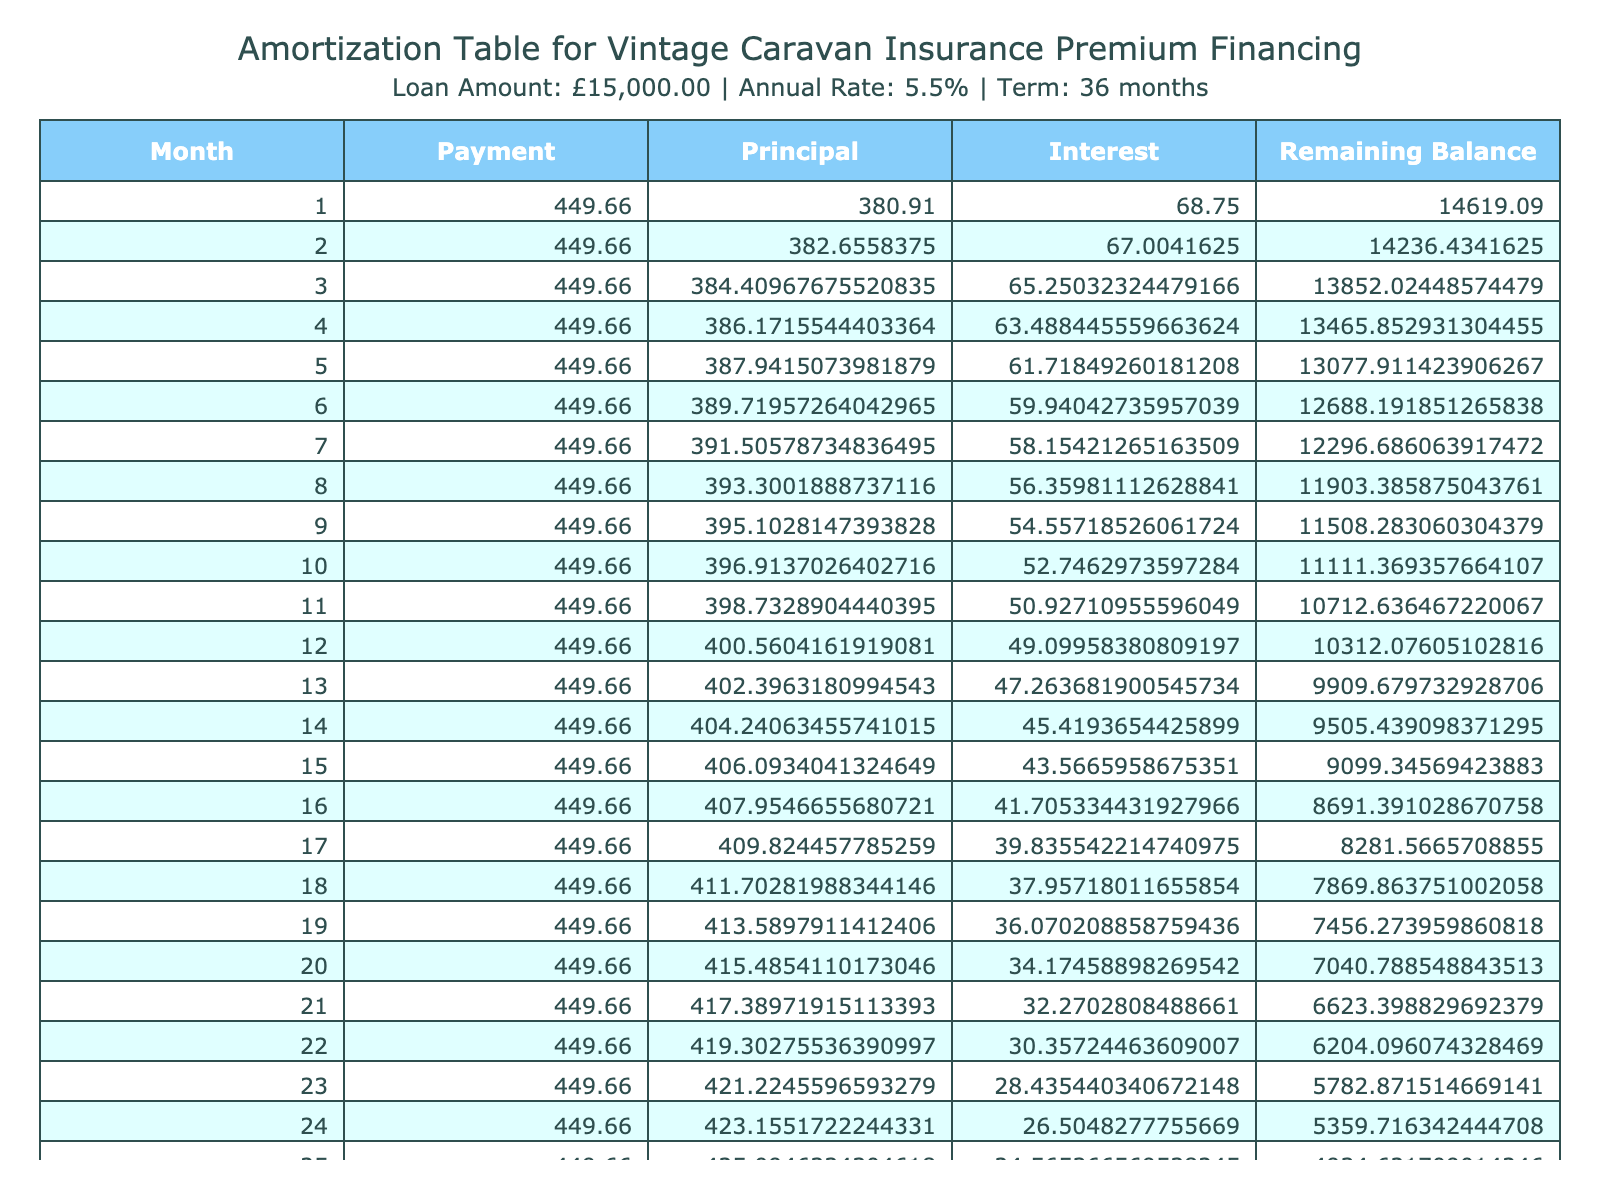What is the loan amount for the vintage caravan insurance? The loan amount is specified in the table under the "Loan Amount" column. It shows that the loan amount is £15,000.
Answer: £15,000 What is the monthly payment for the insurance premium financing? The monthly payment is shown in the "Monthly Payment" column, which indicates the amount to be paid each month. Here, it is £449.66.
Answer: £449.66 How much total interest will be paid over the loan term? The total interest paid over the loan term is listed in the "Total Interest" column. According to the table, it is £1,108.75.
Answer: £1,108.75 What is the total payment amount for the entire loan? The total payment signifies how much will be paid in total at the end of the loan term and is provided in the "Total Payment" column. It shows £16,108.75.
Answer: £16,108.75 Is the loan term longer than two years? The loan term is expressed in months. Since 36 months equals 3 years, we confirm that the loan term is indeed longer than two years.
Answer: Yes What is the average monthly payment if the loan was for 48 months instead of 36? If the loan term were extended to 48 months, we would recalculate using the same loan amount and interest rate. The average monthly payment would change from £449.66 to about £367.18.
Answer: £367.18 How much is the principal amount paid in the first month? To find the principal paid in the first month, we examine the "Principal" column for the first entry. The table states that this amount is £418.84.
Answer: £418.84 What is the remaining balance after the first month? The remaining balance after the first month can be located in the "Remaining Balance" column for the first entry. The table indicates that the remaining balance is £14,581.16.
Answer: £14,581.16 If someone wanted to pay off the loan early after 24 months, how much would they have paid in total without any prepayment penalties? To find this, we calculate the sum of all monthly payments made in the first 24 months. Each payment is £449.66, so for 24 months the total would be 24 * £449.66 = £10,792.84.
Answer: £10,792.84 